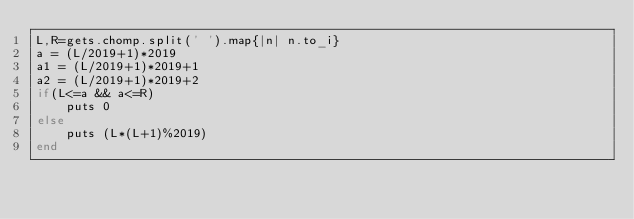Convert code to text. <code><loc_0><loc_0><loc_500><loc_500><_Ruby_>L,R=gets.chomp.split(' ').map{|n| n.to_i}
a = (L/2019+1)*2019
a1 = (L/2019+1)*2019+1
a2 = (L/2019+1)*2019+2
if(L<=a && a<=R)
	puts 0
else
	puts (L*(L+1)%2019)
end

</code> 